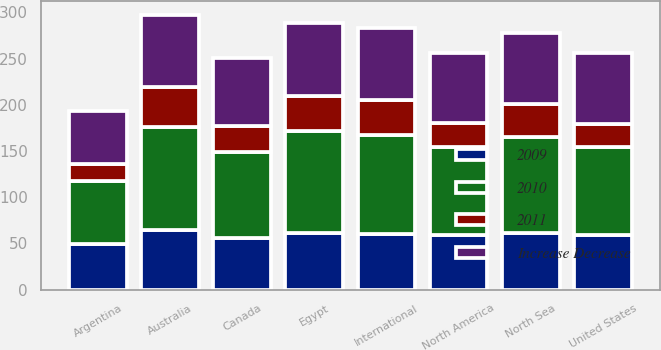Convert chart. <chart><loc_0><loc_0><loc_500><loc_500><stacked_bar_chart><ecel><fcel>United States<fcel>Canada<fcel>North America<fcel>Egypt<fcel>Australia<fcel>North Sea<fcel>Argentina<fcel>International<nl><fcel>2010<fcel>95.51<fcel>93.19<fcel>95.27<fcel>109.92<fcel>111.22<fcel>104.09<fcel>68.02<fcel>106.67<nl><fcel>2011<fcel>25<fcel>28<fcel>26<fcel>38<fcel>44<fcel>36<fcel>18<fcel>38<nl><fcel>Increase Decrease<fcel>76.13<fcel>72.83<fcel>75.69<fcel>79.45<fcel>77.32<fcel>76.66<fcel>57.47<fcel>77.21<nl><fcel>2009<fcel>59.06<fcel>56.16<fcel>58.64<fcel>61.34<fcel>64.42<fcel>60.91<fcel>49.42<fcel>60.58<nl></chart> 